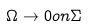<formula> <loc_0><loc_0><loc_500><loc_500>\Omega \rightarrow 0 o n \Sigma</formula> 